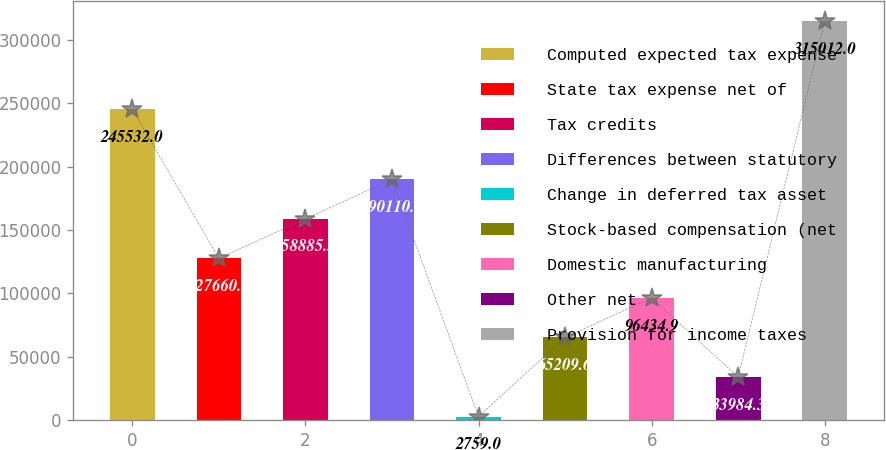Convert chart. <chart><loc_0><loc_0><loc_500><loc_500><bar_chart><fcel>Computed expected tax expense<fcel>State tax expense net of<fcel>Tax credits<fcel>Differences between statutory<fcel>Change in deferred tax asset<fcel>Stock-based compensation (net<fcel>Domestic manufacturing<fcel>Other net<fcel>Provision for income taxes<nl><fcel>245532<fcel>127660<fcel>158886<fcel>190111<fcel>2759<fcel>65209.6<fcel>96434.9<fcel>33984.3<fcel>315012<nl></chart> 